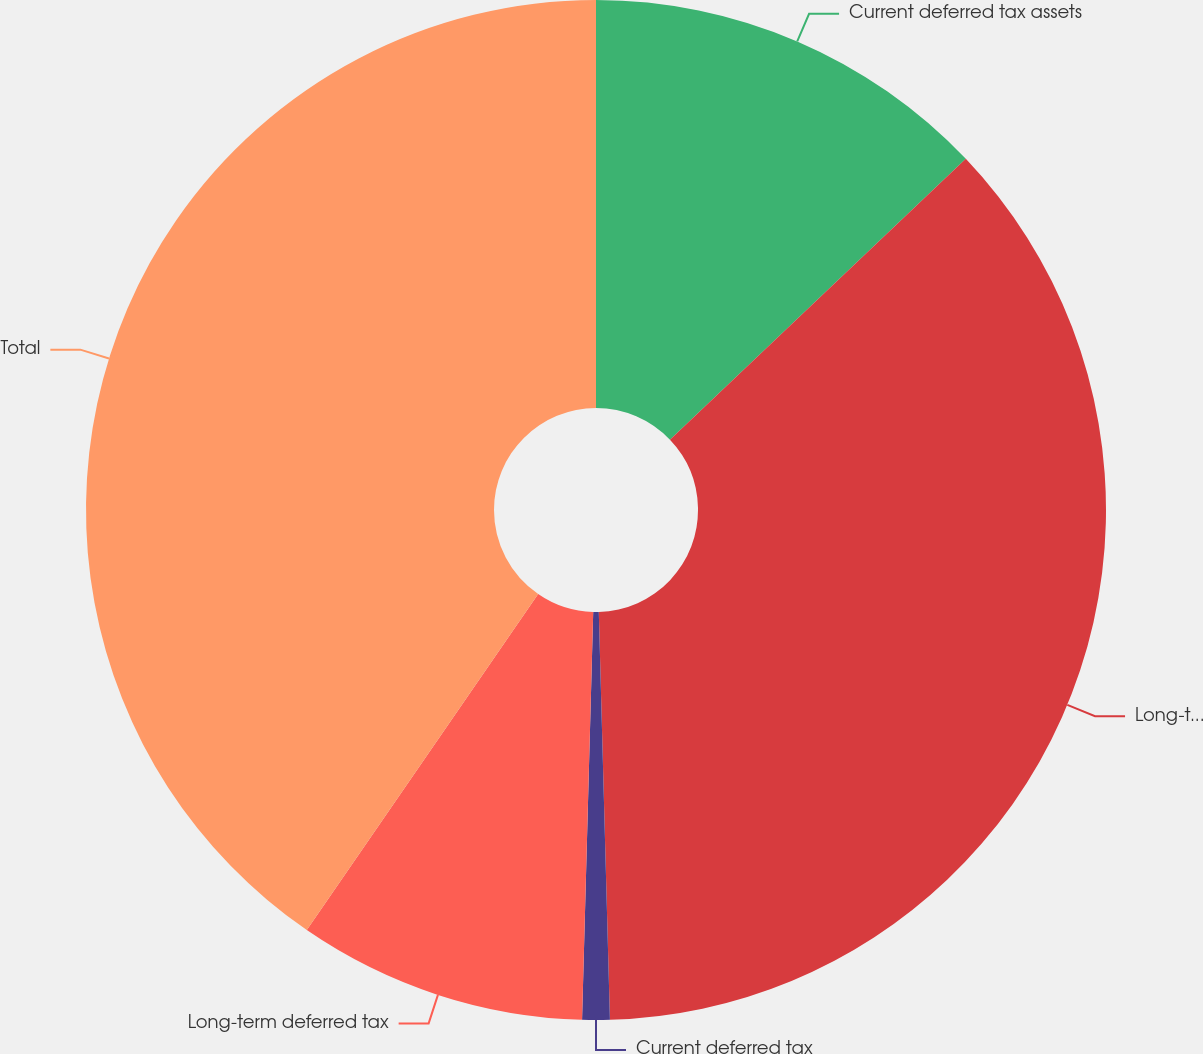<chart> <loc_0><loc_0><loc_500><loc_500><pie_chart><fcel>Current deferred tax assets<fcel>Long-term deferred tax assets<fcel>Current deferred tax<fcel>Long-term deferred tax<fcel>Total<nl><fcel>12.91%<fcel>36.65%<fcel>0.87%<fcel>9.16%<fcel>40.4%<nl></chart> 